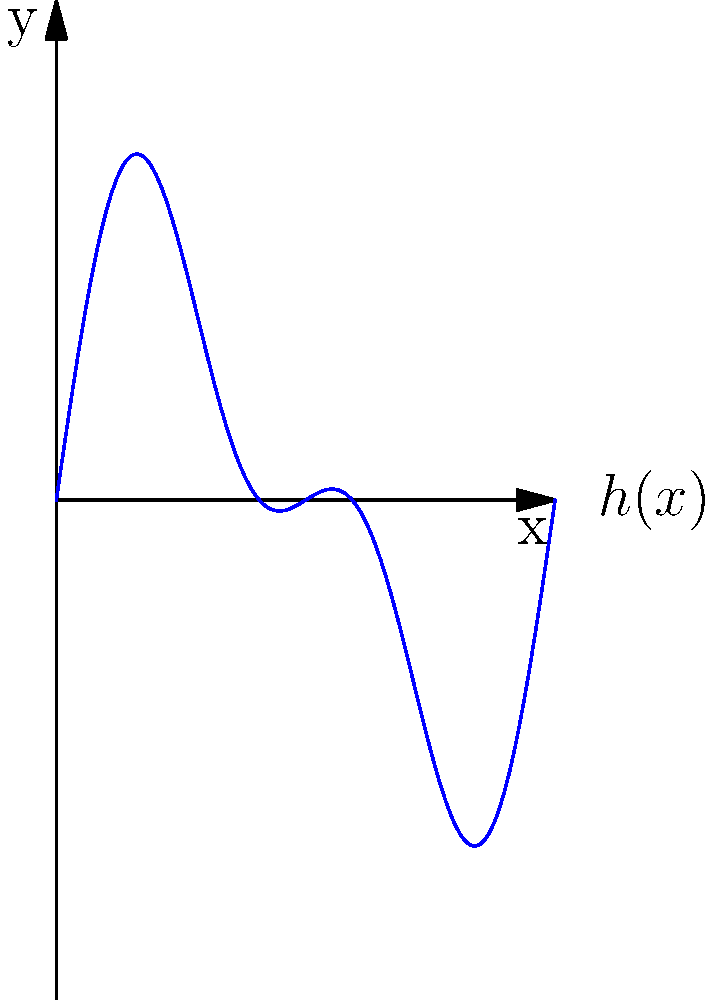Consider the wave function $h(x) = 0.5\sin(2\pi x) + 0.3\sin(4\pi x)$ representing a simplified ocean surface in a virtual environment. Calculate the average height of the surface over the interval $[0, 1]$ by evaluating the integral:

$$\int_0^1 h(x) dx$$ To solve this problem, we'll follow these steps:

1) The given wave function is $h(x) = 0.5\sin(2\pi x) + 0.3\sin(4\pi x)$

2) We need to integrate this function from 0 to 1:

   $$\int_0^1 [0.5\sin(2\pi x) + 0.3\sin(4\pi x)] dx$$

3) We can split this into two integrals:

   $$0.5\int_0^1 \sin(2\pi x)dx + 0.3\int_0^1 \sin(4\pi x)dx$$

4) For the first integral, let $u = 2\pi x$, so $du = 2\pi dx$ or $dx = \frac{1}{2\pi}du$
   When $x = 0$, $u = 0$; when $x = 1$, $u = 2\pi$

   $$0.5 \cdot \frac{1}{2\pi}\int_0^{2\pi} \sin(u)du$$

5) Similarly for the second integral, let $v = 4\pi x$, so $dx = \frac{1}{4\pi}dv$
   When $x = 0$, $v = 0$; when $x = 1$, $v = 4\pi$

   $$0.3 \cdot \frac{1}{4\pi}\int_0^{4\pi} \sin(v)dv$$

6) We know that $\int \sin(x)dx = -\cos(x) + C$

7) Applying this to both integrals:

   $$0.5 \cdot \frac{1}{2\pi}[-\cos(u)]_0^{2\pi} + 0.3 \cdot \frac{1}{4\pi}[-\cos(v)]_0^{4\pi}$$

8) Evaluating:

   $$0.5 \cdot \frac{1}{2\pi}[-\cos(2\pi) + \cos(0)] + 0.3 \cdot \frac{1}{4\pi}[-\cos(4\pi) + \cos(0)]$$

9) $\cos(2\pi) = \cos(4\pi) = \cos(0) = 1$, so all terms cancel out:

   $$0.5 \cdot \frac{1}{2\pi}[0] + 0.3 \cdot \frac{1}{4\pi}[0] = 0$$

Therefore, the average height of the surface over the interval $[0, 1]$ is 0.
Answer: 0 